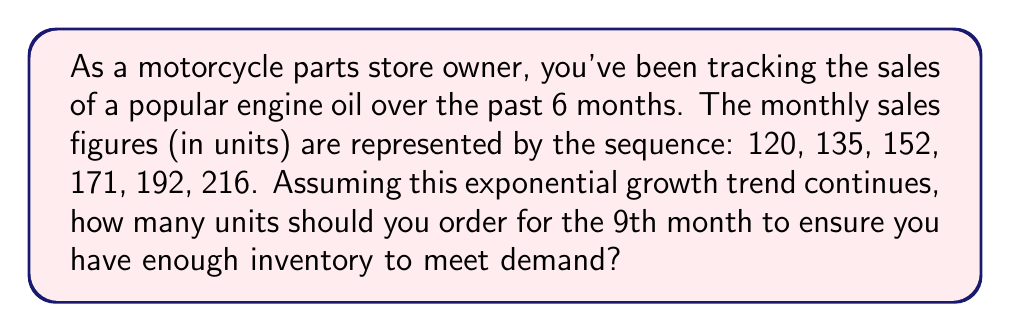Help me with this question. To solve this problem, we need to:
1. Identify the growth rate
2. Use the exponential growth formula to project sales for the 9th month

Step 1: Identify the growth rate
Let's call the growth rate $r$. We can find it by dividing any term by the previous term:

$r = \frac{135}{120} = \frac{152}{135} = \frac{171}{152} = \frac{192}{171} = \frac{216}{192} = 1.125$

This means the sales are growing by 12.5% each month.

Step 2: Use the exponential growth formula
The exponential growth formula is:

$A = P(1 + r)^n$

Where:
$A$ = final amount
$P$ = initial amount
$r$ = growth rate
$n$ = number of periods

We know:
$P = 120$ (first month's sales)
$r = 0.125$ (12.5% growth rate)
$n = 8$ (we want to project to the 9th month, which is 8 periods after the first month)

Let's plug these into the formula:

$A = 120(1 + 0.125)^8$

$A = 120(1.125)^8$

$A = 120(2.5725)$

$A = 308.7$

Since we can't order fractional units, we should round up to ensure we have enough inventory.
Answer: 309 units 